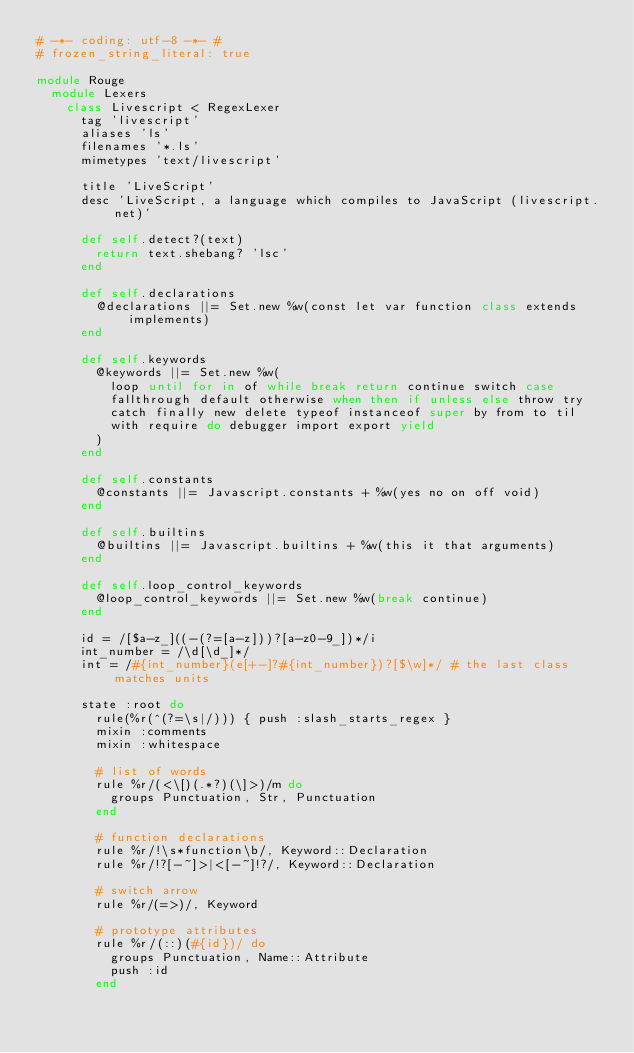Convert code to text. <code><loc_0><loc_0><loc_500><loc_500><_Ruby_># -*- coding: utf-8 -*- #
# frozen_string_literal: true

module Rouge
  module Lexers
    class Livescript < RegexLexer
      tag 'livescript'
      aliases 'ls'
      filenames '*.ls'
      mimetypes 'text/livescript'

      title 'LiveScript'
      desc 'LiveScript, a language which compiles to JavaScript (livescript.net)'

      def self.detect?(text)
        return text.shebang? 'lsc'
      end

      def self.declarations
        @declarations ||= Set.new %w(const let var function class extends implements)
      end

      def self.keywords
        @keywords ||= Set.new %w(
          loop until for in of while break return continue switch case
          fallthrough default otherwise when then if unless else throw try
          catch finally new delete typeof instanceof super by from to til
          with require do debugger import export yield
        )
      end

      def self.constants
        @constants ||= Javascript.constants + %w(yes no on off void)
      end

      def self.builtins
        @builtins ||= Javascript.builtins + %w(this it that arguments)
      end

      def self.loop_control_keywords
        @loop_control_keywords ||= Set.new %w(break continue)
      end

      id = /[$a-z_]((-(?=[a-z]))?[a-z0-9_])*/i
      int_number = /\d[\d_]*/
      int = /#{int_number}(e[+-]?#{int_number})?[$\w]*/ # the last class matches units

      state :root do
        rule(%r(^(?=\s|/))) { push :slash_starts_regex }
        mixin :comments
        mixin :whitespace

        # list of words
        rule %r/(<\[)(.*?)(\]>)/m do
          groups Punctuation, Str, Punctuation
        end

        # function declarations
        rule %r/!\s*function\b/, Keyword::Declaration
        rule %r/!?[-~]>|<[-~]!?/, Keyword::Declaration

        # switch arrow
        rule %r/(=>)/, Keyword

        # prototype attributes
        rule %r/(::)(#{id})/ do
          groups Punctuation, Name::Attribute
          push :id
        end</code> 